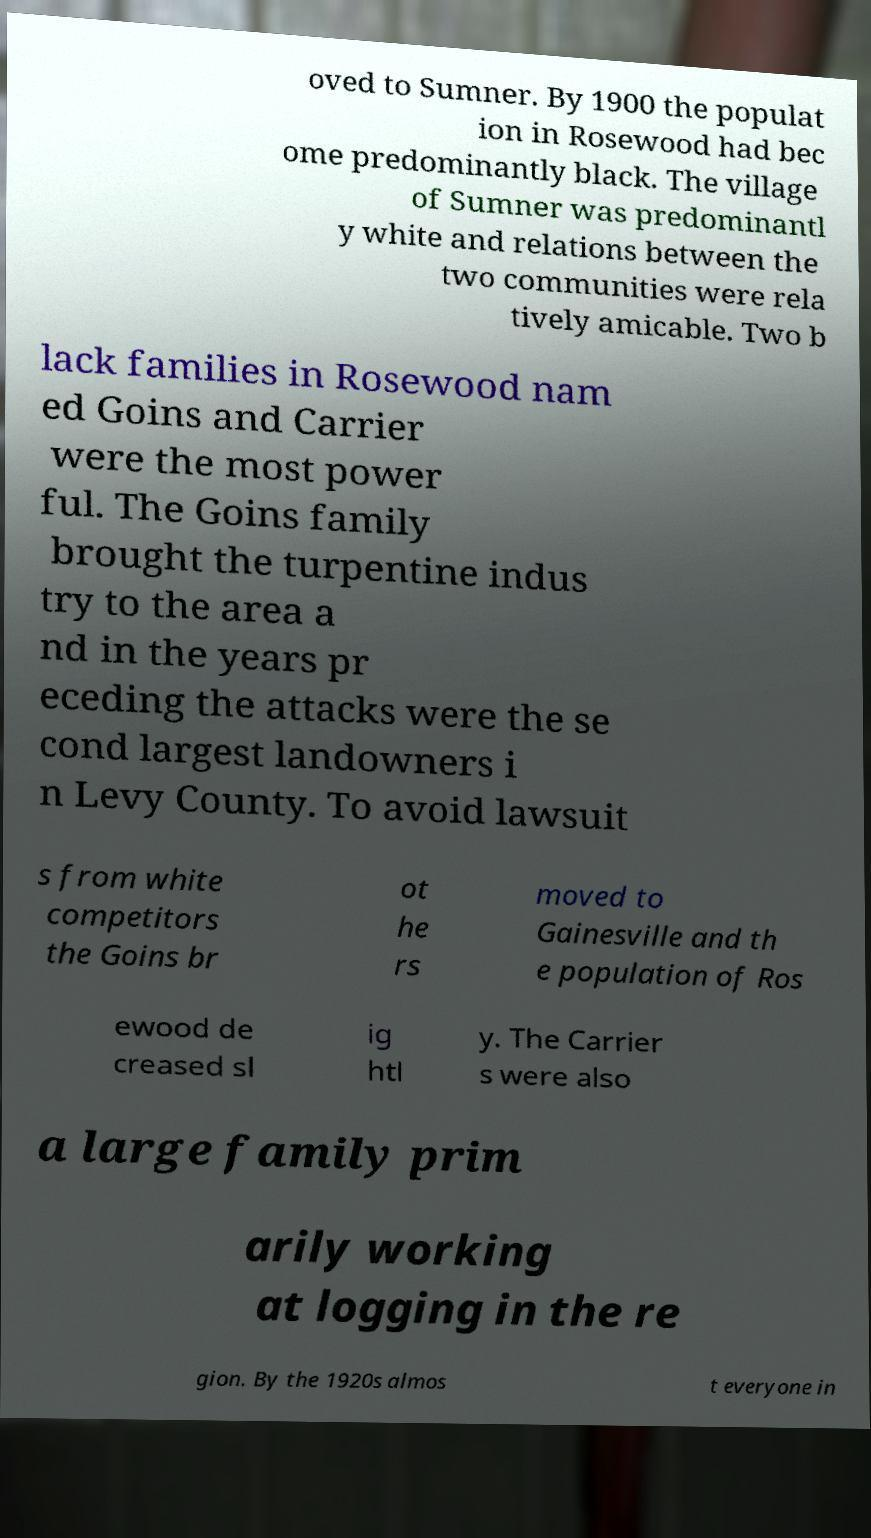Can you read and provide the text displayed in the image?This photo seems to have some interesting text. Can you extract and type it out for me? oved to Sumner. By 1900 the populat ion in Rosewood had bec ome predominantly black. The village of Sumner was predominantl y white and relations between the two communities were rela tively amicable. Two b lack families in Rosewood nam ed Goins and Carrier were the most power ful. The Goins family brought the turpentine indus try to the area a nd in the years pr eceding the attacks were the se cond largest landowners i n Levy County. To avoid lawsuit s from white competitors the Goins br ot he rs moved to Gainesville and th e population of Ros ewood de creased sl ig htl y. The Carrier s were also a large family prim arily working at logging in the re gion. By the 1920s almos t everyone in 